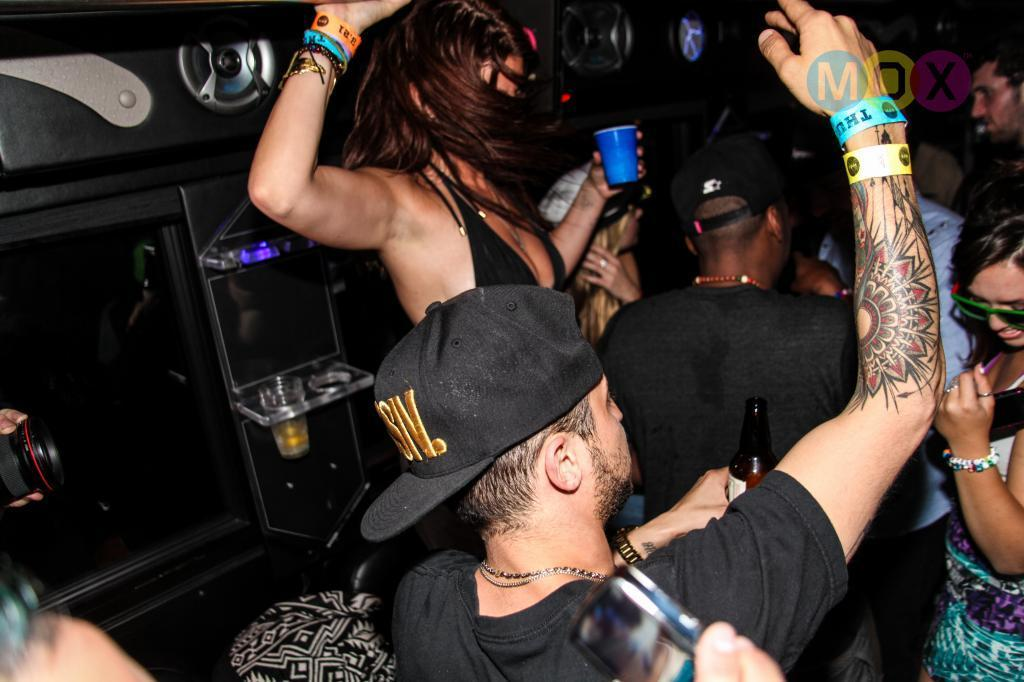What are the persons in the image doing? The persons in the image are in dancing poses. What are the persons holding in their hands? The persons are holding cups, bottles, and a camera. What can be seen in the background of the image? There is a music deck in the background of the image. What is placed on the music deck? There is a glass placed on the music deck. What type of wrench can be seen in the image? There is no wrench present in the image. How many toes are visible on the persons in the image? The image does not show the toes of the persons, so it cannot be determined how many are visible. 